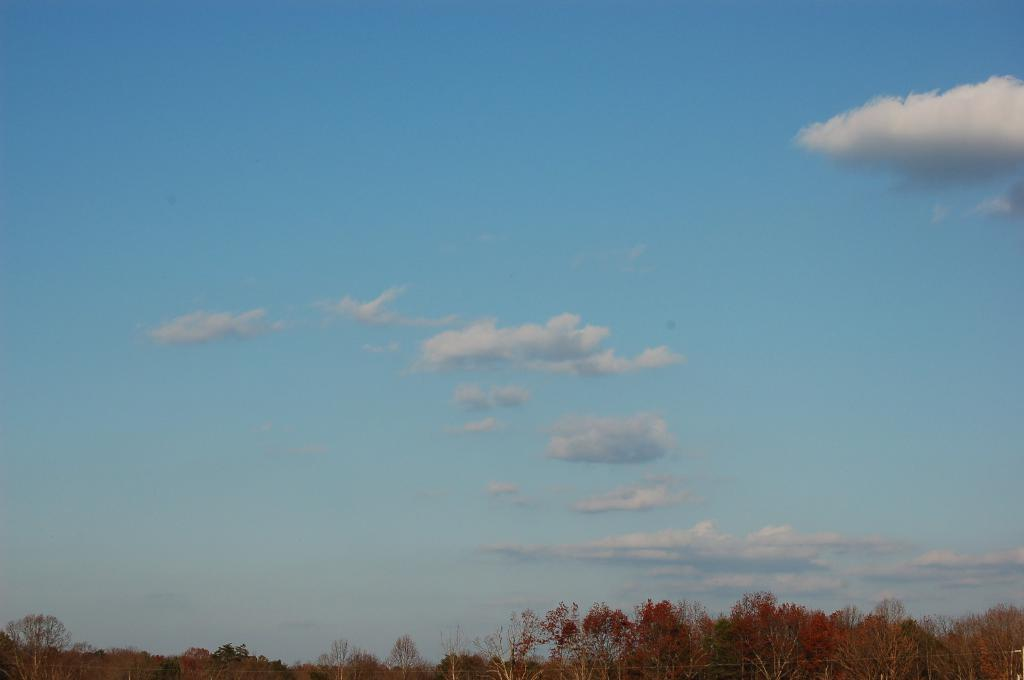What type of vegetation can be seen in the image? There are trees in the image. What is the condition of the sky in the image? The sky is cloudy in the image. Can you see any screws being used as bait in the image? There are no screws or bait present in the image; it features trees and a cloudy sky. 